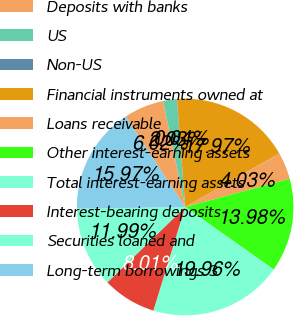Convert chart. <chart><loc_0><loc_0><loc_500><loc_500><pie_chart><fcel>Deposits with banks<fcel>US<fcel>Non-US<fcel>Financial instruments owned at<fcel>Loans receivable<fcel>Other interest-earning assets<fcel>Total interest-earning assets<fcel>Interest-bearing deposits<fcel>Securities loaned and<fcel>Long-term borrowings 3<nl><fcel>6.02%<fcel>2.03%<fcel>0.04%<fcel>17.97%<fcel>4.03%<fcel>13.98%<fcel>19.96%<fcel>8.01%<fcel>11.99%<fcel>15.97%<nl></chart> 